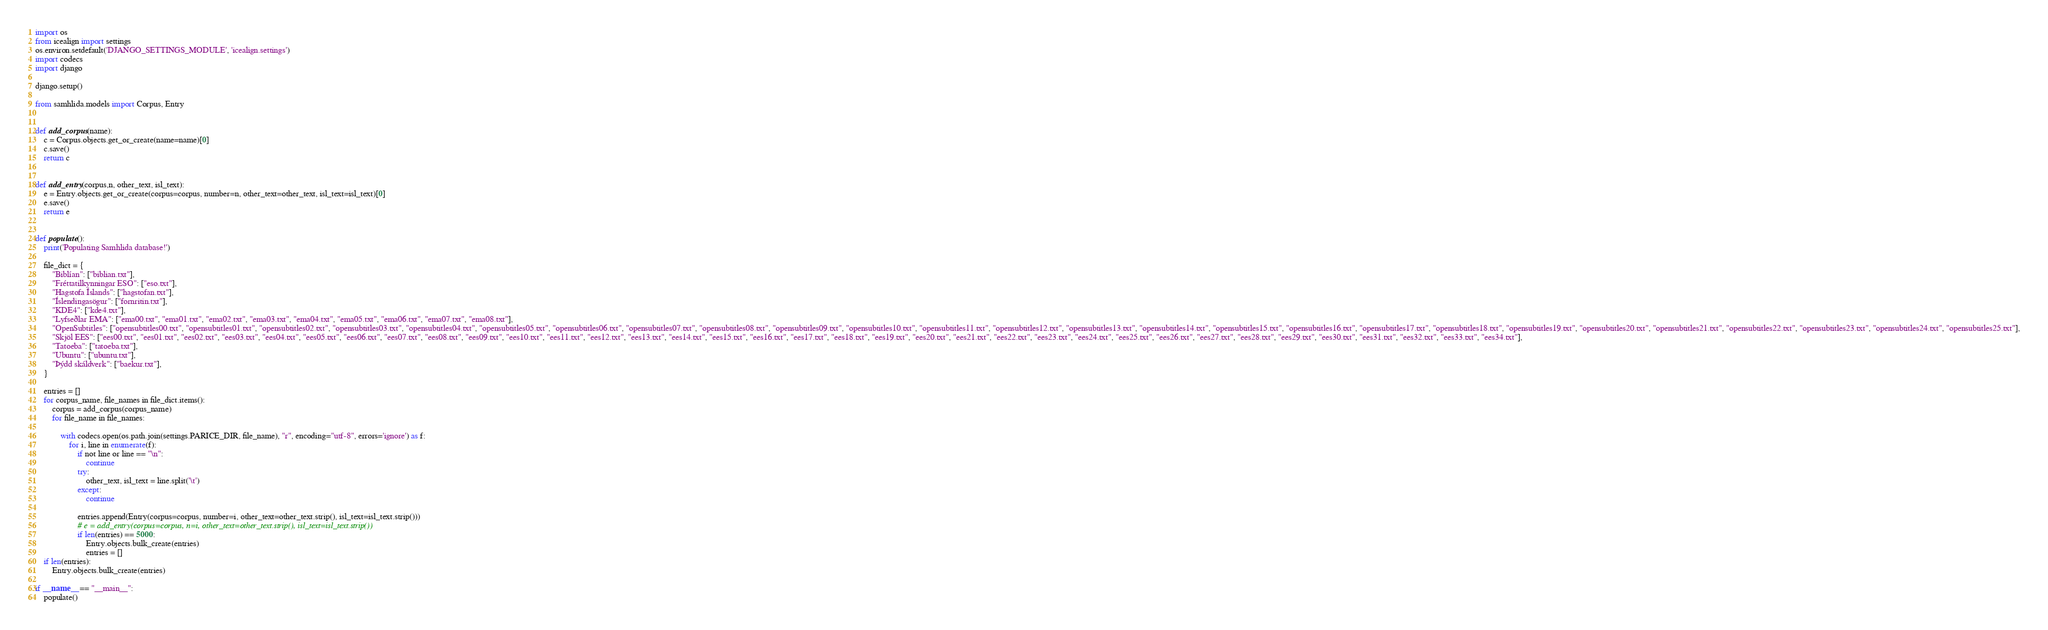<code> <loc_0><loc_0><loc_500><loc_500><_Python_>import os
from icealign import settings
os.environ.setdefault('DJANGO_SETTINGS_MODULE', 'icealign.settings')
import codecs
import django

django.setup()

from samhlida.models import Corpus, Entry


def add_corpus(name):
    c = Corpus.objects.get_or_create(name=name)[0]
    c.save()
    return c


def add_entry(corpus,n, other_text, isl_text):
    e = Entry.objects.get_or_create(corpus=corpus, number=n, other_text=other_text, isl_text=isl_text)[0]
    e.save()
    return e


def populate():
    print('Populating Samhlida database!')

    file_dict = {
        "Biblían": ["biblian.txt"],
        "Fréttatilkynningar ESO": ["eso.txt"],
        "Hagstofa Íslands": ["hagstofan.txt"],
        "Íslendingasögur": ["fornritin.txt"],
        "KDE4": ["kde4.txt"],
        "Lyfseðlar EMA": ["ema00.txt", "ema01.txt", "ema02.txt", "ema03.txt", "ema04.txt", "ema05.txt", "ema06.txt", "ema07.txt", "ema08.txt"],
        "OpenSubtitles": ["opensubtitles00.txt", "opensubtitles01.txt", "opensubtitles02.txt", "opensubtitles03.txt", "opensubtitles04.txt", "opensubtitles05.txt", "opensubtitles06.txt", "opensubtitles07.txt", "opensubtitles08.txt", "opensubtitles09.txt", "opensubtitles10.txt", "opensubtitles11.txt", "opensubtitles12.txt", "opensubtitles13.txt", "opensubtitles14.txt", "opensubtitles15.txt", "opensubtitles16.txt", "opensubtitles17.txt", "opensubtitles18.txt", "opensubtitles19.txt", "opensubtitles20.txt", "opensubtitles21.txt", "opensubtitles22.txt", "opensubtitles23.txt", "opensubtitles24.txt", "opensubtitles25.txt"],
        "Skjöl EES": ["ees00.txt", "ees01.txt", "ees02.txt", "ees03.txt", "ees04.txt", "ees05.txt", "ees06.txt", "ees07.txt", "ees08.txt", "ees09.txt", "ees10.txt", "ees11.txt", "ees12.txt", "ees13.txt", "ees14.txt", "ees15.txt", "ees16.txt", "ees17.txt", "ees18.txt", "ees19.txt", "ees20.txt", "ees21.txt", "ees22.txt", "ees23.txt", "ees24.txt", "ees25.txt", "ees26.txt", "ees27.txt", "ees28.txt", "ees29.txt", "ees30.txt", "ees31.txt", "ees32.txt", "ees33.txt", "ees34.txt"],
        "Tatoeba": ["tatoeba.txt"],
        "Ubuntu": ["ubuntu.txt"],
        "Þýdd skáldverk": ["baekur.txt"],
    }

    entries = []
    for corpus_name, file_names in file_dict.items():
        corpus = add_corpus(corpus_name)
        for file_name in file_names:

            with codecs.open(os.path.join(settings.PARICE_DIR, file_name), "r", encoding="utf-8", errors='ignore') as f:
                for i, line in enumerate(f):
                    if not line or line == "\n":
                        continue
                    try:
                        other_text, isl_text = line.split('\t')
                    except:
                        continue

                    entries.append(Entry(corpus=corpus, number=i, other_text=other_text.strip(), isl_text=isl_text.strip()))
                    # e = add_entry(corpus=corpus, n=i, other_text=other_text.strip(), isl_text=isl_text.strip())
                    if len(entries) == 5000:
                        Entry.objects.bulk_create(entries)
                        entries = []
    if len(entries):
        Entry.objects.bulk_create(entries)

if __name__ == "__main__":
    populate()
</code> 